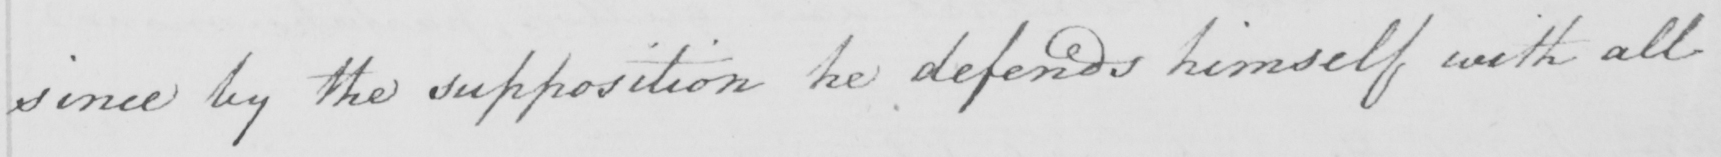Can you read and transcribe this handwriting? since by the supposition he defends himself with all 